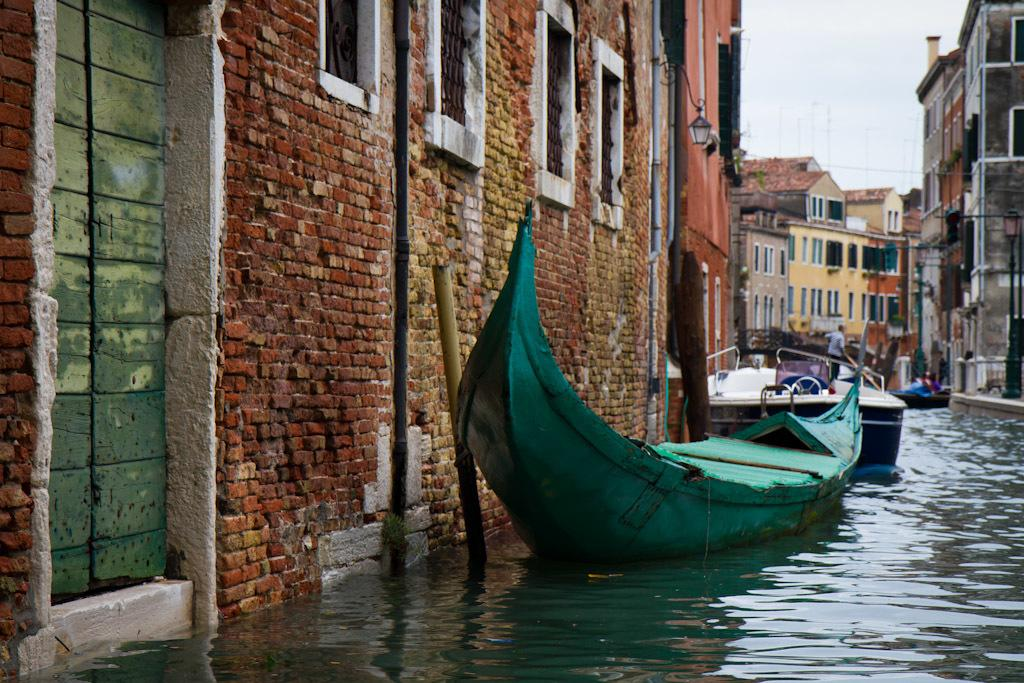What is located in the foreground of the image? There are boats in the foreground of the image. Where are the boats situated? The boats are on the water. What can be seen on the left side of the image? There are buildings and a light on the left side of the image. What is visible in the background of the image? There are buildings and the sky in the background of the image. What type of silk is being used to cover the foot of the person in the image? There is no person or silk present in the image; it features boats on the water with buildings and a light on the left side. 